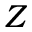<formula> <loc_0><loc_0><loc_500><loc_500>Z</formula> 